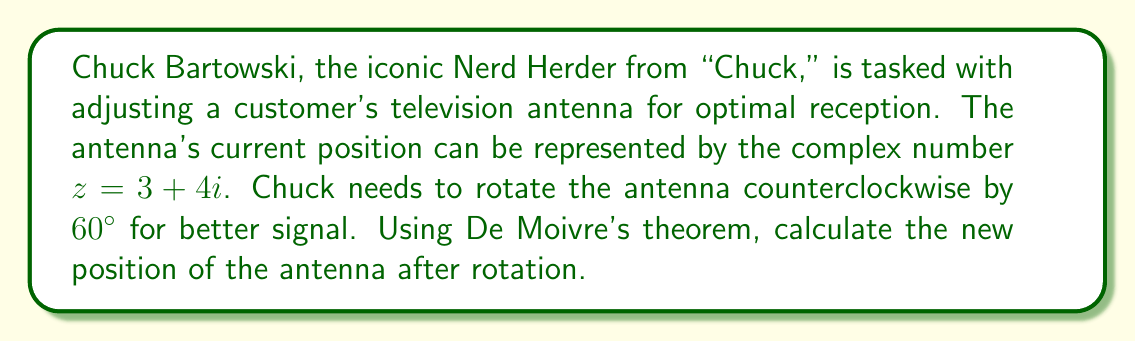Show me your answer to this math problem. Let's approach this step-by-step using De Moivre's theorem:

1) First, we need to express the initial position $z = 3 + 4i$ in polar form:

   $z = r(\cos\theta + i\sin\theta)$

   where $r = \sqrt{3^2 + 4^2} = 5$, and $\theta = \arctan(\frac{4}{3})$

2) Now, we can write $z$ as:

   $z = 5(\cos\theta + i\sin\theta)$

3) To rotate by $60°$ counterclockwise, we multiply by $\cos60° + i\sin60°$:

   $z_{new} = 5(\cos\theta + i\sin\theta)(\cos60° + i\sin60°)$

4) Using De Moivre's theorem, this is equivalent to:

   $z_{new} = 5[\cos(\theta + 60°) + i\sin(\theta + 60°)]$

5) To get back to rectangular form, we need to calculate:

   $x = 5\cos(\theta + 60°)$
   $y = 5\sin(\theta + 60°)$

6) We know that $\cos60° = \frac{1}{2}$ and $\sin60° = \frac{\sqrt{3}}{2}$

7) Using the angle addition formulas:

   $x = 5[\cos\theta\cos60° - \sin\theta\sin60°] = 5[\frac{3}{5} \cdot \frac{1}{2} - \frac{4}{5} \cdot \frac{\sqrt{3}}{2}] = \frac{3}{2} - 2\sqrt{3}$

   $y = 5[\sin\theta\cos60° + \cos\theta\sin60°] = 5[\frac{4}{5} \cdot \frac{1}{2} + \frac{3}{5} \cdot \frac{\sqrt{3}}{2}] = 1 + \frac{3\sqrt{3}}{2}$

Therefore, the new position of the antenna after rotation is $z_{new} = (\frac{3}{2} - 2\sqrt{3}) + (1 + \frac{3\sqrt{3}}{2})i$.
Answer: $z_{new} = (\frac{3}{2} - 2\sqrt{3}) + (1 + \frac{3\sqrt{3}}{2})i$ 